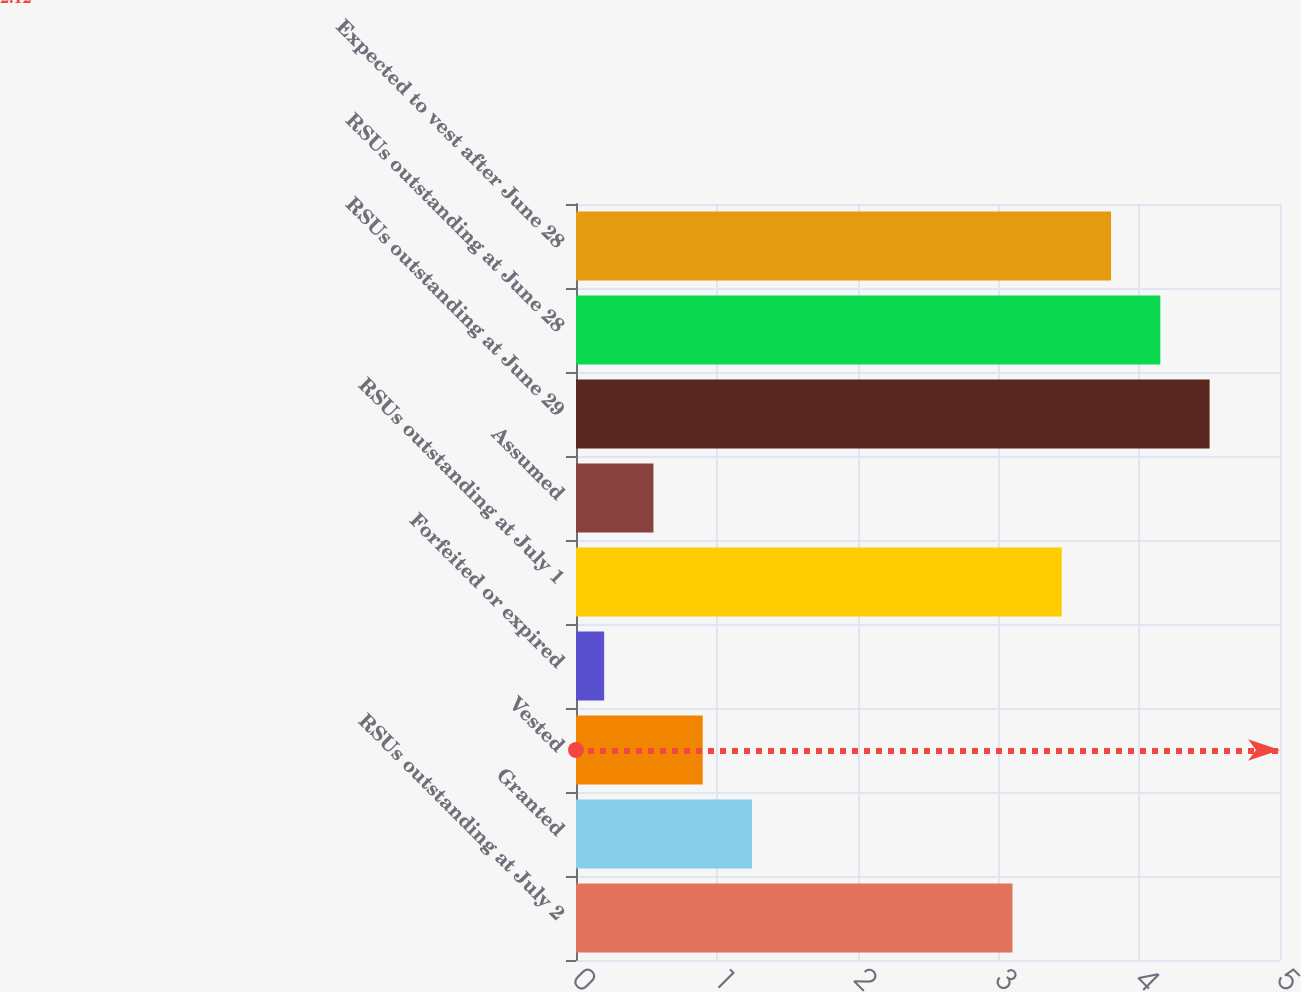Convert chart to OTSL. <chart><loc_0><loc_0><loc_500><loc_500><bar_chart><fcel>RSUs outstanding at July 2<fcel>Granted<fcel>Vested<fcel>Forfeited or expired<fcel>RSUs outstanding at July 1<fcel>Assumed<fcel>RSUs outstanding at June 29<fcel>RSUs outstanding at June 28<fcel>Expected to vest after June 28<nl><fcel>3.1<fcel>1.25<fcel>0.9<fcel>0.2<fcel>3.45<fcel>0.55<fcel>4.5<fcel>4.15<fcel>3.8<nl></chart> 